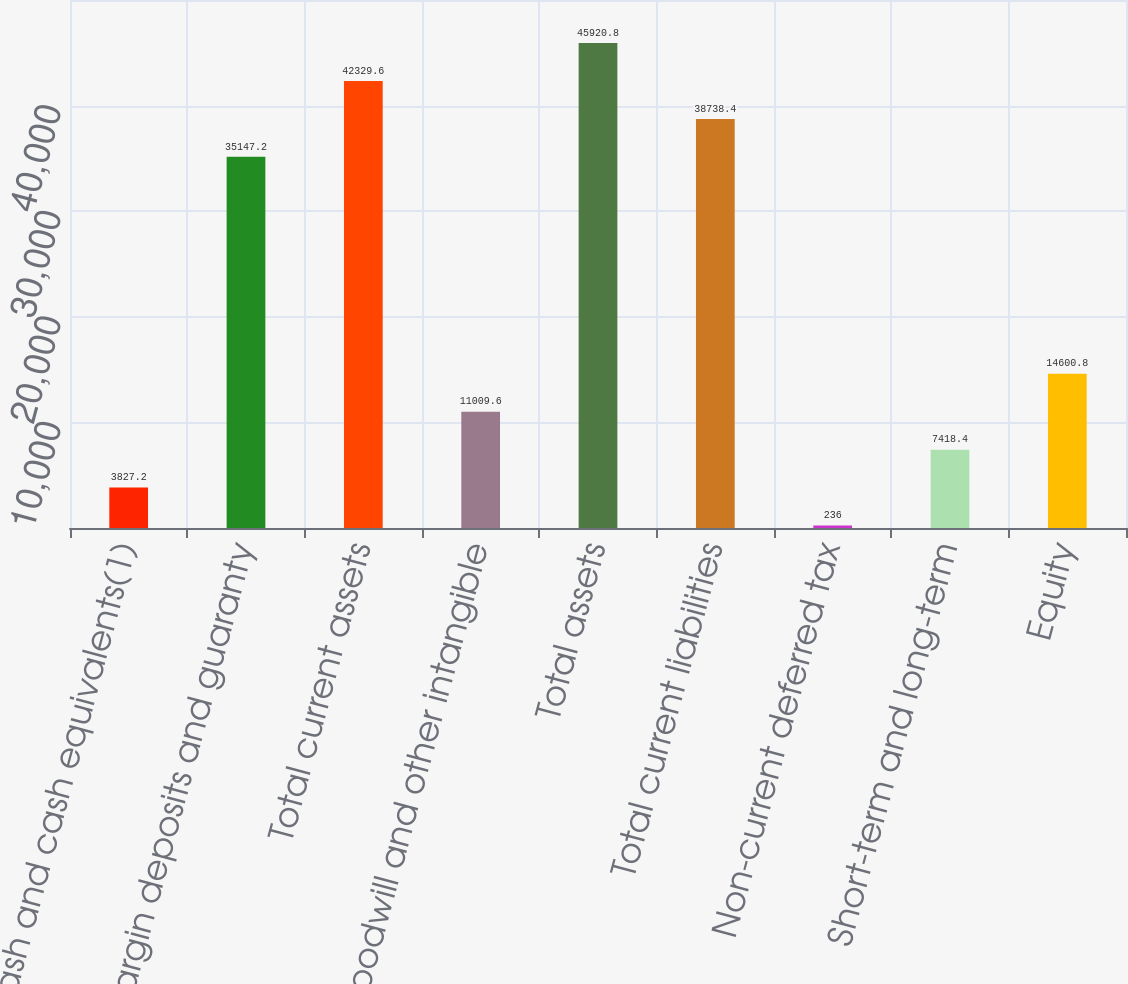<chart> <loc_0><loc_0><loc_500><loc_500><bar_chart><fcel>Cash and cash equivalents(1)<fcel>Margin deposits and guaranty<fcel>Total current assets<fcel>Goodwill and other intangible<fcel>Total assets<fcel>Total current liabilities<fcel>Non-current deferred tax<fcel>Short-term and long-term<fcel>Equity<nl><fcel>3827.2<fcel>35147.2<fcel>42329.6<fcel>11009.6<fcel>45920.8<fcel>38738.4<fcel>236<fcel>7418.4<fcel>14600.8<nl></chart> 